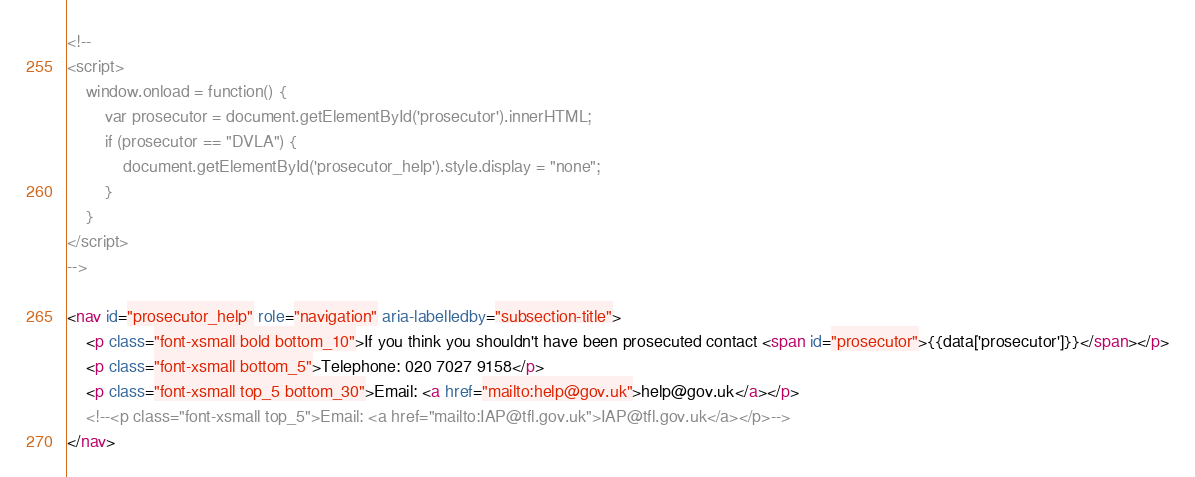Convert code to text. <code><loc_0><loc_0><loc_500><loc_500><_HTML_><!--
<script>
    window.onload = function() {
        var prosecutor = document.getElementById('prosecutor').innerHTML;
        if (prosecutor == "DVLA") {
            document.getElementById('prosecutor_help').style.display = "none";
        }
    }
</script>
-->

<nav id="prosecutor_help" role="navigation" aria-labelledby="subsection-title">
    <p class="font-xsmall bold bottom_10">If you think you shouldn't have been prosecuted contact <span id="prosecutor">{{data['prosecutor']}}</span></p>
    <p class="font-xsmall bottom_5">Telephone: 020 7027 9158</p>
    <p class="font-xsmall top_5 bottom_30">Email: <a href="mailto:help@gov.uk">help@gov.uk</a></p>
    <!--<p class="font-xsmall top_5">Email: <a href="mailto:IAP@tfl.gov.uk">IAP@tfl.gov.uk</a></p>-->
</nav>
</code> 